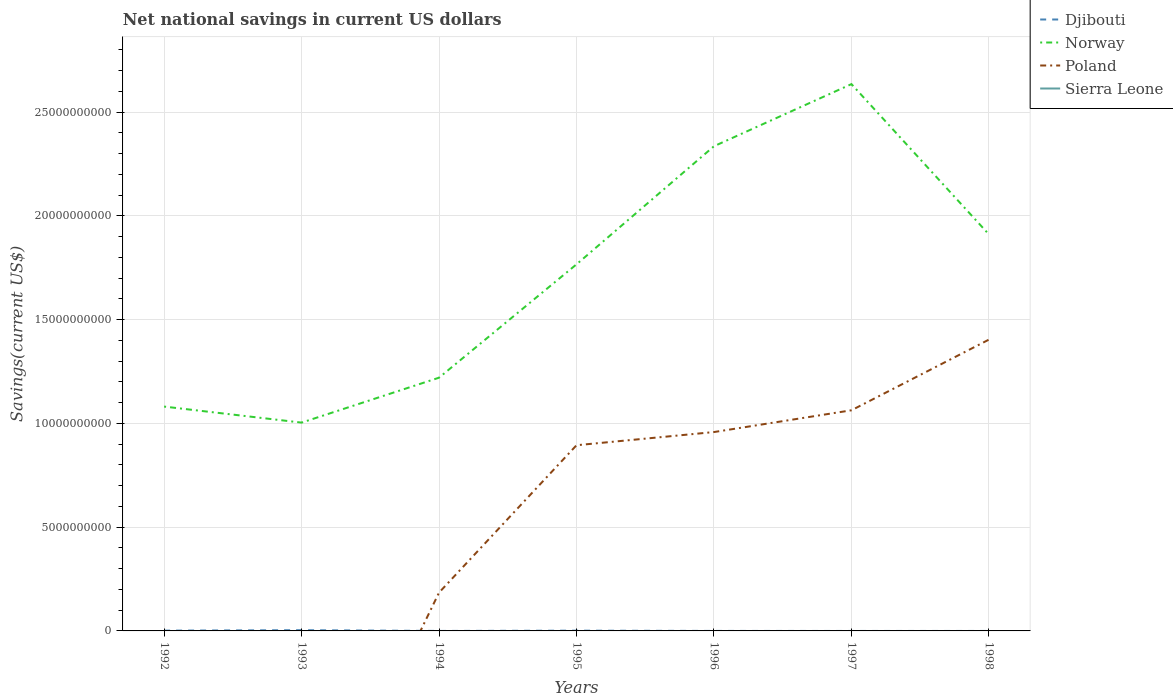Is the number of lines equal to the number of legend labels?
Your response must be concise. No. What is the total net national savings in Poland in the graph?
Your answer should be very brief. -7.74e+09. What is the difference between the highest and the second highest net national savings in Djibouti?
Make the answer very short. 3.60e+07. How many lines are there?
Provide a succinct answer. 3. How many years are there in the graph?
Offer a very short reply. 7. What is the difference between two consecutive major ticks on the Y-axis?
Keep it short and to the point. 5.00e+09. Does the graph contain any zero values?
Provide a succinct answer. Yes. Does the graph contain grids?
Keep it short and to the point. Yes. How many legend labels are there?
Give a very brief answer. 4. What is the title of the graph?
Offer a very short reply. Net national savings in current US dollars. What is the label or title of the Y-axis?
Your response must be concise. Savings(current US$). What is the Savings(current US$) in Djibouti in 1992?
Ensure brevity in your answer.  1.38e+07. What is the Savings(current US$) in Norway in 1992?
Provide a short and direct response. 1.08e+1. What is the Savings(current US$) of Poland in 1992?
Give a very brief answer. 0. What is the Savings(current US$) in Sierra Leone in 1992?
Your response must be concise. 0. What is the Savings(current US$) of Djibouti in 1993?
Give a very brief answer. 3.60e+07. What is the Savings(current US$) in Norway in 1993?
Your response must be concise. 1.00e+1. What is the Savings(current US$) of Poland in 1993?
Keep it short and to the point. 0. What is the Savings(current US$) in Djibouti in 1994?
Make the answer very short. 0. What is the Savings(current US$) of Norway in 1994?
Offer a terse response. 1.22e+1. What is the Savings(current US$) in Poland in 1994?
Your answer should be compact. 1.85e+09. What is the Savings(current US$) in Djibouti in 1995?
Keep it short and to the point. 1.28e+07. What is the Savings(current US$) in Norway in 1995?
Your response must be concise. 1.77e+1. What is the Savings(current US$) of Poland in 1995?
Provide a succinct answer. 8.95e+09. What is the Savings(current US$) of Djibouti in 1996?
Provide a short and direct response. 0. What is the Savings(current US$) of Norway in 1996?
Offer a very short reply. 2.34e+1. What is the Savings(current US$) in Poland in 1996?
Your answer should be compact. 9.59e+09. What is the Savings(current US$) of Sierra Leone in 1996?
Make the answer very short. 0. What is the Savings(current US$) of Norway in 1997?
Your answer should be compact. 2.64e+1. What is the Savings(current US$) in Poland in 1997?
Provide a succinct answer. 1.06e+1. What is the Savings(current US$) of Djibouti in 1998?
Offer a terse response. 0. What is the Savings(current US$) in Norway in 1998?
Your answer should be compact. 1.91e+1. What is the Savings(current US$) in Poland in 1998?
Your response must be concise. 1.40e+1. Across all years, what is the maximum Savings(current US$) in Djibouti?
Ensure brevity in your answer.  3.60e+07. Across all years, what is the maximum Savings(current US$) of Norway?
Keep it short and to the point. 2.64e+1. Across all years, what is the maximum Savings(current US$) of Poland?
Keep it short and to the point. 1.40e+1. Across all years, what is the minimum Savings(current US$) of Norway?
Provide a short and direct response. 1.00e+1. What is the total Savings(current US$) in Djibouti in the graph?
Keep it short and to the point. 6.26e+07. What is the total Savings(current US$) of Norway in the graph?
Your answer should be very brief. 1.20e+11. What is the total Savings(current US$) of Poland in the graph?
Ensure brevity in your answer.  4.51e+1. What is the total Savings(current US$) in Sierra Leone in the graph?
Give a very brief answer. 0. What is the difference between the Savings(current US$) of Djibouti in 1992 and that in 1993?
Offer a terse response. -2.22e+07. What is the difference between the Savings(current US$) of Norway in 1992 and that in 1993?
Ensure brevity in your answer.  7.73e+08. What is the difference between the Savings(current US$) of Norway in 1992 and that in 1994?
Make the answer very short. -1.39e+09. What is the difference between the Savings(current US$) in Djibouti in 1992 and that in 1995?
Your response must be concise. 9.78e+05. What is the difference between the Savings(current US$) in Norway in 1992 and that in 1995?
Your answer should be very brief. -6.86e+09. What is the difference between the Savings(current US$) in Norway in 1992 and that in 1996?
Your answer should be compact. -1.25e+1. What is the difference between the Savings(current US$) in Norway in 1992 and that in 1997?
Offer a very short reply. -1.55e+1. What is the difference between the Savings(current US$) in Norway in 1992 and that in 1998?
Your answer should be compact. -8.30e+09. What is the difference between the Savings(current US$) of Norway in 1993 and that in 1994?
Provide a short and direct response. -2.17e+09. What is the difference between the Savings(current US$) in Djibouti in 1993 and that in 1995?
Your answer should be compact. 2.32e+07. What is the difference between the Savings(current US$) in Norway in 1993 and that in 1995?
Your answer should be compact. -7.63e+09. What is the difference between the Savings(current US$) in Norway in 1993 and that in 1996?
Make the answer very short. -1.33e+1. What is the difference between the Savings(current US$) of Norway in 1993 and that in 1997?
Keep it short and to the point. -1.63e+1. What is the difference between the Savings(current US$) of Norway in 1993 and that in 1998?
Your answer should be very brief. -9.07e+09. What is the difference between the Savings(current US$) in Norway in 1994 and that in 1995?
Provide a succinct answer. -5.46e+09. What is the difference between the Savings(current US$) of Poland in 1994 and that in 1995?
Provide a succinct answer. -7.10e+09. What is the difference between the Savings(current US$) in Norway in 1994 and that in 1996?
Your response must be concise. -1.12e+1. What is the difference between the Savings(current US$) in Poland in 1994 and that in 1996?
Give a very brief answer. -7.74e+09. What is the difference between the Savings(current US$) in Norway in 1994 and that in 1997?
Your response must be concise. -1.41e+1. What is the difference between the Savings(current US$) of Poland in 1994 and that in 1997?
Make the answer very short. -8.79e+09. What is the difference between the Savings(current US$) of Norway in 1994 and that in 1998?
Your response must be concise. -6.91e+09. What is the difference between the Savings(current US$) in Poland in 1994 and that in 1998?
Your response must be concise. -1.22e+1. What is the difference between the Savings(current US$) of Norway in 1995 and that in 1996?
Ensure brevity in your answer.  -5.69e+09. What is the difference between the Savings(current US$) of Poland in 1995 and that in 1996?
Offer a terse response. -6.35e+08. What is the difference between the Savings(current US$) in Norway in 1995 and that in 1997?
Provide a short and direct response. -8.69e+09. What is the difference between the Savings(current US$) of Poland in 1995 and that in 1997?
Give a very brief answer. -1.68e+09. What is the difference between the Savings(current US$) in Norway in 1995 and that in 1998?
Give a very brief answer. -1.44e+09. What is the difference between the Savings(current US$) in Poland in 1995 and that in 1998?
Your answer should be very brief. -5.09e+09. What is the difference between the Savings(current US$) of Norway in 1996 and that in 1997?
Offer a very short reply. -2.99e+09. What is the difference between the Savings(current US$) of Poland in 1996 and that in 1997?
Your answer should be compact. -1.05e+09. What is the difference between the Savings(current US$) in Norway in 1996 and that in 1998?
Ensure brevity in your answer.  4.25e+09. What is the difference between the Savings(current US$) of Poland in 1996 and that in 1998?
Make the answer very short. -4.46e+09. What is the difference between the Savings(current US$) in Norway in 1997 and that in 1998?
Offer a very short reply. 7.24e+09. What is the difference between the Savings(current US$) in Poland in 1997 and that in 1998?
Your answer should be compact. -3.41e+09. What is the difference between the Savings(current US$) of Djibouti in 1992 and the Savings(current US$) of Norway in 1993?
Make the answer very short. -1.00e+1. What is the difference between the Savings(current US$) of Djibouti in 1992 and the Savings(current US$) of Norway in 1994?
Make the answer very short. -1.22e+1. What is the difference between the Savings(current US$) of Djibouti in 1992 and the Savings(current US$) of Poland in 1994?
Provide a short and direct response. -1.83e+09. What is the difference between the Savings(current US$) in Norway in 1992 and the Savings(current US$) in Poland in 1994?
Provide a short and direct response. 8.97e+09. What is the difference between the Savings(current US$) of Djibouti in 1992 and the Savings(current US$) of Norway in 1995?
Ensure brevity in your answer.  -1.77e+1. What is the difference between the Savings(current US$) in Djibouti in 1992 and the Savings(current US$) in Poland in 1995?
Make the answer very short. -8.94e+09. What is the difference between the Savings(current US$) of Norway in 1992 and the Savings(current US$) of Poland in 1995?
Keep it short and to the point. 1.86e+09. What is the difference between the Savings(current US$) of Djibouti in 1992 and the Savings(current US$) of Norway in 1996?
Make the answer very short. -2.33e+1. What is the difference between the Savings(current US$) of Djibouti in 1992 and the Savings(current US$) of Poland in 1996?
Give a very brief answer. -9.57e+09. What is the difference between the Savings(current US$) of Norway in 1992 and the Savings(current US$) of Poland in 1996?
Make the answer very short. 1.23e+09. What is the difference between the Savings(current US$) in Djibouti in 1992 and the Savings(current US$) in Norway in 1997?
Your response must be concise. -2.63e+1. What is the difference between the Savings(current US$) in Djibouti in 1992 and the Savings(current US$) in Poland in 1997?
Make the answer very short. -1.06e+1. What is the difference between the Savings(current US$) in Norway in 1992 and the Savings(current US$) in Poland in 1997?
Ensure brevity in your answer.  1.79e+08. What is the difference between the Savings(current US$) of Djibouti in 1992 and the Savings(current US$) of Norway in 1998?
Keep it short and to the point. -1.91e+1. What is the difference between the Savings(current US$) in Djibouti in 1992 and the Savings(current US$) in Poland in 1998?
Give a very brief answer. -1.40e+1. What is the difference between the Savings(current US$) of Norway in 1992 and the Savings(current US$) of Poland in 1998?
Keep it short and to the point. -3.23e+09. What is the difference between the Savings(current US$) of Djibouti in 1993 and the Savings(current US$) of Norway in 1994?
Your answer should be very brief. -1.22e+1. What is the difference between the Savings(current US$) in Djibouti in 1993 and the Savings(current US$) in Poland in 1994?
Make the answer very short. -1.81e+09. What is the difference between the Savings(current US$) in Norway in 1993 and the Savings(current US$) in Poland in 1994?
Make the answer very short. 8.19e+09. What is the difference between the Savings(current US$) of Djibouti in 1993 and the Savings(current US$) of Norway in 1995?
Your response must be concise. -1.76e+1. What is the difference between the Savings(current US$) of Djibouti in 1993 and the Savings(current US$) of Poland in 1995?
Your answer should be compact. -8.91e+09. What is the difference between the Savings(current US$) of Norway in 1993 and the Savings(current US$) of Poland in 1995?
Offer a terse response. 1.09e+09. What is the difference between the Savings(current US$) in Djibouti in 1993 and the Savings(current US$) in Norway in 1996?
Your answer should be compact. -2.33e+1. What is the difference between the Savings(current US$) of Djibouti in 1993 and the Savings(current US$) of Poland in 1996?
Ensure brevity in your answer.  -9.55e+09. What is the difference between the Savings(current US$) of Norway in 1993 and the Savings(current US$) of Poland in 1996?
Offer a very short reply. 4.55e+08. What is the difference between the Savings(current US$) in Djibouti in 1993 and the Savings(current US$) in Norway in 1997?
Provide a succinct answer. -2.63e+1. What is the difference between the Savings(current US$) in Djibouti in 1993 and the Savings(current US$) in Poland in 1997?
Your response must be concise. -1.06e+1. What is the difference between the Savings(current US$) in Norway in 1993 and the Savings(current US$) in Poland in 1997?
Provide a short and direct response. -5.94e+08. What is the difference between the Savings(current US$) of Djibouti in 1993 and the Savings(current US$) of Norway in 1998?
Your response must be concise. -1.91e+1. What is the difference between the Savings(current US$) in Djibouti in 1993 and the Savings(current US$) in Poland in 1998?
Offer a very short reply. -1.40e+1. What is the difference between the Savings(current US$) of Norway in 1993 and the Savings(current US$) of Poland in 1998?
Offer a very short reply. -4.00e+09. What is the difference between the Savings(current US$) in Norway in 1994 and the Savings(current US$) in Poland in 1995?
Make the answer very short. 3.26e+09. What is the difference between the Savings(current US$) of Norway in 1994 and the Savings(current US$) of Poland in 1996?
Make the answer very short. 2.62e+09. What is the difference between the Savings(current US$) in Norway in 1994 and the Savings(current US$) in Poland in 1997?
Offer a very short reply. 1.57e+09. What is the difference between the Savings(current US$) in Norway in 1994 and the Savings(current US$) in Poland in 1998?
Offer a terse response. -1.83e+09. What is the difference between the Savings(current US$) of Djibouti in 1995 and the Savings(current US$) of Norway in 1996?
Offer a very short reply. -2.33e+1. What is the difference between the Savings(current US$) in Djibouti in 1995 and the Savings(current US$) in Poland in 1996?
Your response must be concise. -9.57e+09. What is the difference between the Savings(current US$) of Norway in 1995 and the Savings(current US$) of Poland in 1996?
Make the answer very short. 8.08e+09. What is the difference between the Savings(current US$) of Djibouti in 1995 and the Savings(current US$) of Norway in 1997?
Give a very brief answer. -2.63e+1. What is the difference between the Savings(current US$) in Djibouti in 1995 and the Savings(current US$) in Poland in 1997?
Ensure brevity in your answer.  -1.06e+1. What is the difference between the Savings(current US$) in Norway in 1995 and the Savings(current US$) in Poland in 1997?
Your answer should be very brief. 7.03e+09. What is the difference between the Savings(current US$) of Djibouti in 1995 and the Savings(current US$) of Norway in 1998?
Give a very brief answer. -1.91e+1. What is the difference between the Savings(current US$) in Djibouti in 1995 and the Savings(current US$) in Poland in 1998?
Provide a short and direct response. -1.40e+1. What is the difference between the Savings(current US$) in Norway in 1995 and the Savings(current US$) in Poland in 1998?
Keep it short and to the point. 3.63e+09. What is the difference between the Savings(current US$) in Norway in 1996 and the Savings(current US$) in Poland in 1997?
Your answer should be very brief. 1.27e+1. What is the difference between the Savings(current US$) of Norway in 1996 and the Savings(current US$) of Poland in 1998?
Offer a very short reply. 9.32e+09. What is the difference between the Savings(current US$) in Norway in 1997 and the Savings(current US$) in Poland in 1998?
Provide a short and direct response. 1.23e+1. What is the average Savings(current US$) in Djibouti per year?
Offer a terse response. 8.95e+06. What is the average Savings(current US$) in Norway per year?
Your answer should be very brief. 1.71e+1. What is the average Savings(current US$) in Poland per year?
Provide a succinct answer. 6.44e+09. What is the average Savings(current US$) of Sierra Leone per year?
Offer a terse response. 0. In the year 1992, what is the difference between the Savings(current US$) in Djibouti and Savings(current US$) in Norway?
Give a very brief answer. -1.08e+1. In the year 1993, what is the difference between the Savings(current US$) in Djibouti and Savings(current US$) in Norway?
Give a very brief answer. -1.00e+1. In the year 1994, what is the difference between the Savings(current US$) in Norway and Savings(current US$) in Poland?
Your answer should be compact. 1.04e+1. In the year 1995, what is the difference between the Savings(current US$) of Djibouti and Savings(current US$) of Norway?
Ensure brevity in your answer.  -1.77e+1. In the year 1995, what is the difference between the Savings(current US$) in Djibouti and Savings(current US$) in Poland?
Offer a very short reply. -8.94e+09. In the year 1995, what is the difference between the Savings(current US$) in Norway and Savings(current US$) in Poland?
Make the answer very short. 8.72e+09. In the year 1996, what is the difference between the Savings(current US$) of Norway and Savings(current US$) of Poland?
Provide a succinct answer. 1.38e+1. In the year 1997, what is the difference between the Savings(current US$) in Norway and Savings(current US$) in Poland?
Offer a terse response. 1.57e+1. In the year 1998, what is the difference between the Savings(current US$) in Norway and Savings(current US$) in Poland?
Provide a short and direct response. 5.07e+09. What is the ratio of the Savings(current US$) in Djibouti in 1992 to that in 1993?
Make the answer very short. 0.38. What is the ratio of the Savings(current US$) of Norway in 1992 to that in 1993?
Your answer should be compact. 1.08. What is the ratio of the Savings(current US$) of Norway in 1992 to that in 1994?
Ensure brevity in your answer.  0.89. What is the ratio of the Savings(current US$) in Djibouti in 1992 to that in 1995?
Offer a terse response. 1.08. What is the ratio of the Savings(current US$) in Norway in 1992 to that in 1995?
Your answer should be very brief. 0.61. What is the ratio of the Savings(current US$) in Norway in 1992 to that in 1996?
Make the answer very short. 0.46. What is the ratio of the Savings(current US$) in Norway in 1992 to that in 1997?
Your response must be concise. 0.41. What is the ratio of the Savings(current US$) in Norway in 1992 to that in 1998?
Provide a succinct answer. 0.57. What is the ratio of the Savings(current US$) in Norway in 1993 to that in 1994?
Offer a terse response. 0.82. What is the ratio of the Savings(current US$) of Djibouti in 1993 to that in 1995?
Your answer should be compact. 2.81. What is the ratio of the Savings(current US$) of Norway in 1993 to that in 1995?
Provide a short and direct response. 0.57. What is the ratio of the Savings(current US$) in Norway in 1993 to that in 1996?
Your response must be concise. 0.43. What is the ratio of the Savings(current US$) in Norway in 1993 to that in 1997?
Your response must be concise. 0.38. What is the ratio of the Savings(current US$) of Norway in 1993 to that in 1998?
Your answer should be compact. 0.53. What is the ratio of the Savings(current US$) of Norway in 1994 to that in 1995?
Provide a succinct answer. 0.69. What is the ratio of the Savings(current US$) in Poland in 1994 to that in 1995?
Give a very brief answer. 0.21. What is the ratio of the Savings(current US$) of Norway in 1994 to that in 1996?
Make the answer very short. 0.52. What is the ratio of the Savings(current US$) of Poland in 1994 to that in 1996?
Provide a short and direct response. 0.19. What is the ratio of the Savings(current US$) of Norway in 1994 to that in 1997?
Offer a very short reply. 0.46. What is the ratio of the Savings(current US$) of Poland in 1994 to that in 1997?
Your answer should be very brief. 0.17. What is the ratio of the Savings(current US$) of Norway in 1994 to that in 1998?
Provide a succinct answer. 0.64. What is the ratio of the Savings(current US$) of Poland in 1994 to that in 1998?
Your response must be concise. 0.13. What is the ratio of the Savings(current US$) of Norway in 1995 to that in 1996?
Ensure brevity in your answer.  0.76. What is the ratio of the Savings(current US$) of Poland in 1995 to that in 1996?
Provide a succinct answer. 0.93. What is the ratio of the Savings(current US$) of Norway in 1995 to that in 1997?
Ensure brevity in your answer.  0.67. What is the ratio of the Savings(current US$) in Poland in 1995 to that in 1997?
Keep it short and to the point. 0.84. What is the ratio of the Savings(current US$) in Norway in 1995 to that in 1998?
Provide a short and direct response. 0.92. What is the ratio of the Savings(current US$) in Poland in 1995 to that in 1998?
Give a very brief answer. 0.64. What is the ratio of the Savings(current US$) in Norway in 1996 to that in 1997?
Provide a succinct answer. 0.89. What is the ratio of the Savings(current US$) in Poland in 1996 to that in 1997?
Keep it short and to the point. 0.9. What is the ratio of the Savings(current US$) of Norway in 1996 to that in 1998?
Give a very brief answer. 1.22. What is the ratio of the Savings(current US$) of Poland in 1996 to that in 1998?
Ensure brevity in your answer.  0.68. What is the ratio of the Savings(current US$) in Norway in 1997 to that in 1998?
Offer a very short reply. 1.38. What is the ratio of the Savings(current US$) in Poland in 1997 to that in 1998?
Keep it short and to the point. 0.76. What is the difference between the highest and the second highest Savings(current US$) in Djibouti?
Keep it short and to the point. 2.22e+07. What is the difference between the highest and the second highest Savings(current US$) of Norway?
Give a very brief answer. 2.99e+09. What is the difference between the highest and the second highest Savings(current US$) of Poland?
Provide a succinct answer. 3.41e+09. What is the difference between the highest and the lowest Savings(current US$) in Djibouti?
Keep it short and to the point. 3.60e+07. What is the difference between the highest and the lowest Savings(current US$) in Norway?
Your response must be concise. 1.63e+1. What is the difference between the highest and the lowest Savings(current US$) of Poland?
Provide a short and direct response. 1.40e+1. 